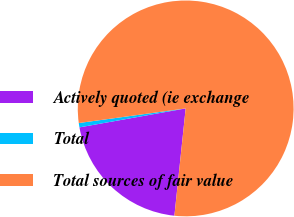Convert chart to OTSL. <chart><loc_0><loc_0><loc_500><loc_500><pie_chart><fcel>Actively quoted (ie exchange<fcel>Total<fcel>Total sources of fair value<nl><fcel>20.52%<fcel>0.65%<fcel>78.82%<nl></chart> 